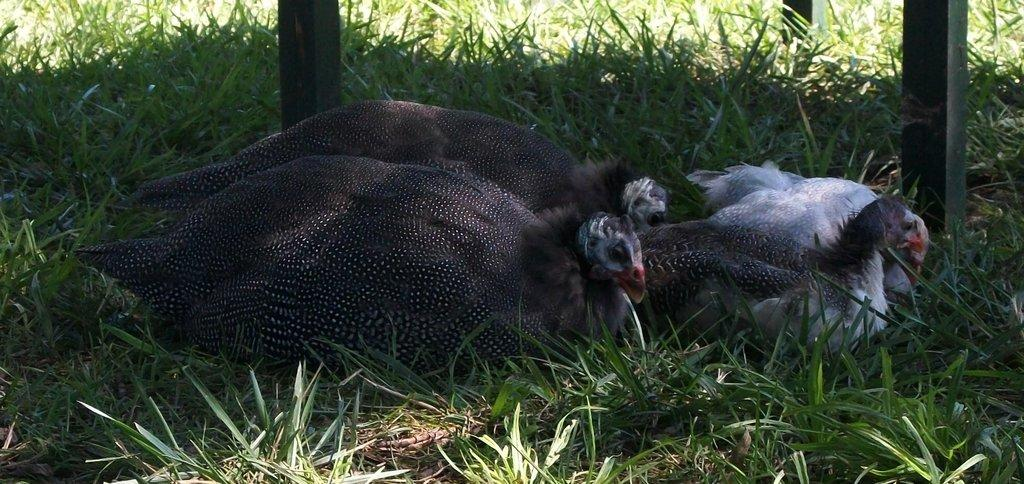What type of animals are on the ground in the image? There are guinea fowls on the ground in the image. What type of vegetation is visible in the image? There is grass visible in the image. What objects can be seen in the image besides the guinea fowls and grass? There are wooden sticks in the image. What type of memory is being used by the guinea fowls in the image? There is no indication in the image that the guinea fowls are using any type of memory. 